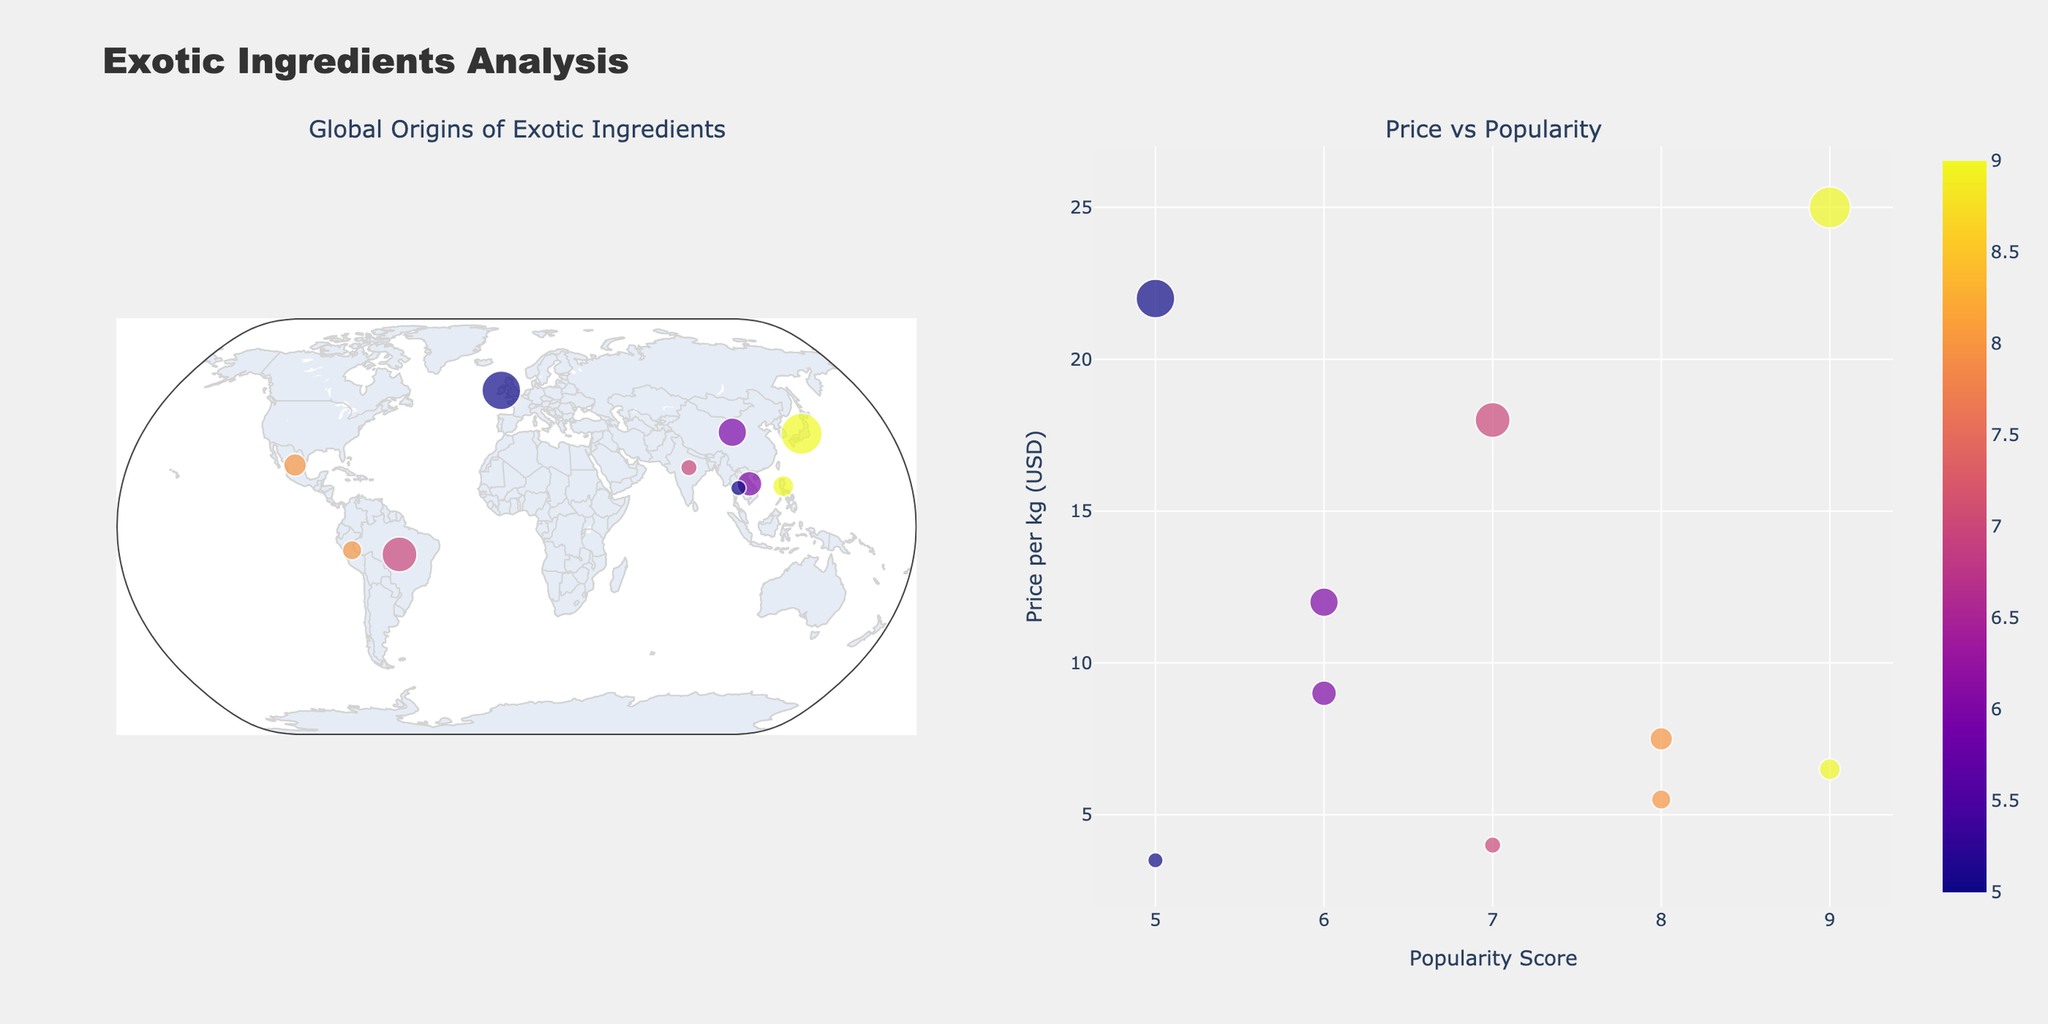What is the title of the scatter plot on the right side of the figure? The title of the scatter plot can be found at the top of the right subplot in the figure. It is usually descriptive of what the plot represents.
Answer: Price vs Popularity Which ingredient has the highest popularity score and where does it originate from? To find the ingredient with the highest popularity score, locate the data point with the highest x-value in the right plot or the corresponding color in the scatter geo subplot.
Answer: Matcha, Japan What is the price per kg of the ingredient with the highest popularity score? Once the ingredient with the highest popularity score is identified (Matcha from Japan), look for its y-coordinate in the scatter plot on the right.
Answer: 25.00 USD How many ingredients have a popularity score greater than 7? Count the data points in the right scatter plot that have an x-value (popularity score) greater than 7.
Answer: 5 Compare the price per kg for Chia Seeds and Turmeric. Which is cheaper and by how much? Identify the y-coordinates for Chia Seeds and Turmeric in the right scatter plot. Subtract the price of Turmeric from the price of Chia Seeds.
Answer: Turmeric is cheaper by 3.50 USD From which country does the ingredient 'Goji Berries' originate, and what is its import route? Locate the ingredient 'Goji Berries' in the scatter geo plot and check its origin and import route in the hover information.
Answer: China, "China -> Netherlands -> Local Supermarket" Which has a higher price per kg, Acai or Dulse Seaweed? Identify the y-values for Acai and Dulse Seaweed in the scatter plot on the right and compare them.
Answer: Dulse Seaweed What is the average price per kg of ingredients originating from Asia? Identify ingredients from the scatter geo plot originating in Asian countries (China, Japan, Philippines, Vietnam, Thailand), sum their prices per kg, and divide by the count of these ingredients.
Answer: 11.4 USD Which ingredient is represented by the largest circle in the scatter geo plot? Identify the largest circle in the scatter geo plot by observing the relative sizes of the data points.
Answer: Matcha Which import route covers the most countries? Examine the import routes listed in the scatter geo plot or hover information, and count the number of countries involved in each route.
Answer: "China -> Netherlands -> Local Supermarket" 